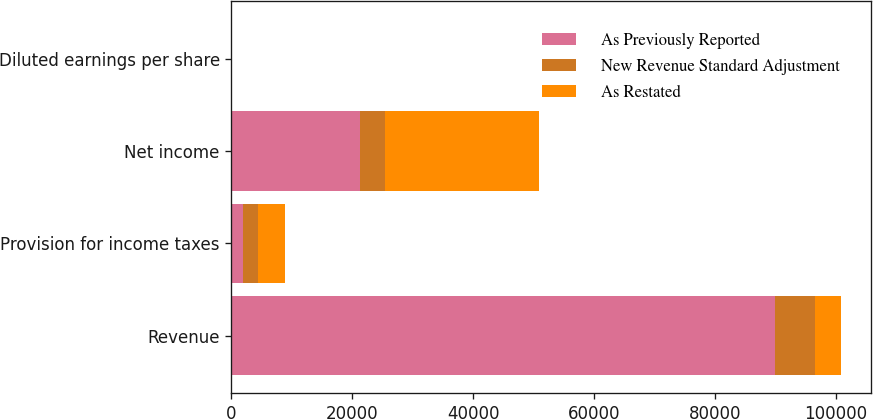<chart> <loc_0><loc_0><loc_500><loc_500><stacked_bar_chart><ecel><fcel>Revenue<fcel>Provision for income taxes<fcel>Net income<fcel>Diluted earnings per share<nl><fcel>As Previously Reported<fcel>89950<fcel>1945<fcel>21204<fcel>2.71<nl><fcel>New Revenue Standard Adjustment<fcel>6621<fcel>2467<fcel>4285<fcel>0.54<nl><fcel>As Restated<fcel>4285<fcel>4412<fcel>25489<fcel>3.25<nl></chart> 